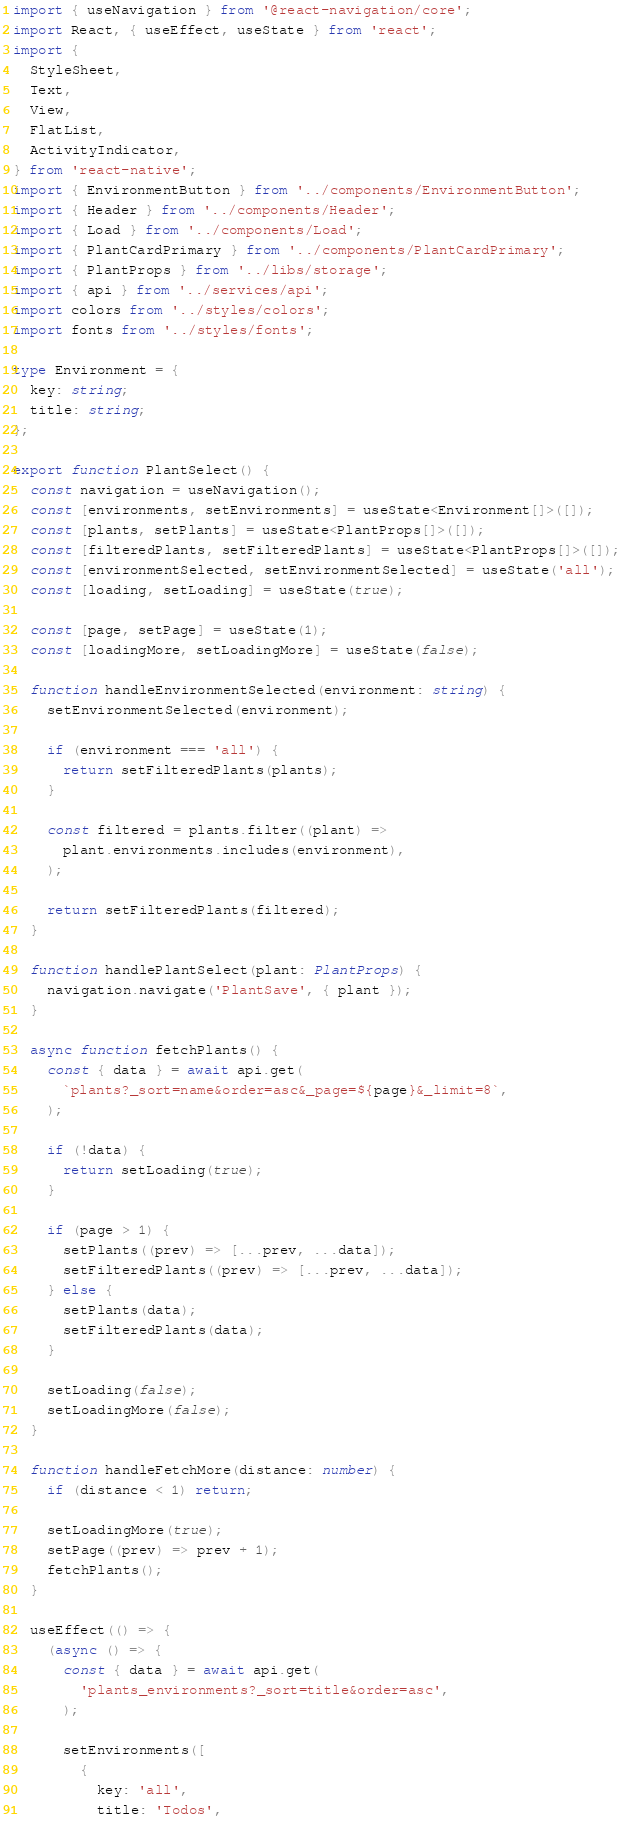<code> <loc_0><loc_0><loc_500><loc_500><_TypeScript_>import { useNavigation } from '@react-navigation/core';
import React, { useEffect, useState } from 'react';
import {
  StyleSheet,
  Text,
  View,
  FlatList,
  ActivityIndicator,
} from 'react-native';
import { EnvironmentButton } from '../components/EnvironmentButton';
import { Header } from '../components/Header';
import { Load } from '../components/Load';
import { PlantCardPrimary } from '../components/PlantCardPrimary';
import { PlantProps } from '../libs/storage';
import { api } from '../services/api';
import colors from '../styles/colors';
import fonts from '../styles/fonts';

type Environment = {
  key: string;
  title: string;
};

export function PlantSelect() {
  const navigation = useNavigation();
  const [environments, setEnvironments] = useState<Environment[]>([]);
  const [plants, setPlants] = useState<PlantProps[]>([]);
  const [filteredPlants, setFilteredPlants] = useState<PlantProps[]>([]);
  const [environmentSelected, setEnvironmentSelected] = useState('all');
  const [loading, setLoading] = useState(true);

  const [page, setPage] = useState(1);
  const [loadingMore, setLoadingMore] = useState(false);

  function handleEnvironmentSelected(environment: string) {
    setEnvironmentSelected(environment);

    if (environment === 'all') {
      return setFilteredPlants(plants);
    }

    const filtered = plants.filter((plant) =>
      plant.environments.includes(environment),
    );

    return setFilteredPlants(filtered);
  }

  function handlePlantSelect(plant: PlantProps) {
    navigation.navigate('PlantSave', { plant });
  }

  async function fetchPlants() {
    const { data } = await api.get(
      `plants?_sort=name&order=asc&_page=${page}&_limit=8`,
    );

    if (!data) {
      return setLoading(true);
    }

    if (page > 1) {
      setPlants((prev) => [...prev, ...data]);
      setFilteredPlants((prev) => [...prev, ...data]);
    } else {
      setPlants(data);
      setFilteredPlants(data);
    }

    setLoading(false);
    setLoadingMore(false);
  }

  function handleFetchMore(distance: number) {
    if (distance < 1) return;

    setLoadingMore(true);
    setPage((prev) => prev + 1);
    fetchPlants();
  }

  useEffect(() => {
    (async () => {
      const { data } = await api.get(
        'plants_environments?_sort=title&order=asc',
      );

      setEnvironments([
        {
          key: 'all',
          title: 'Todos',</code> 